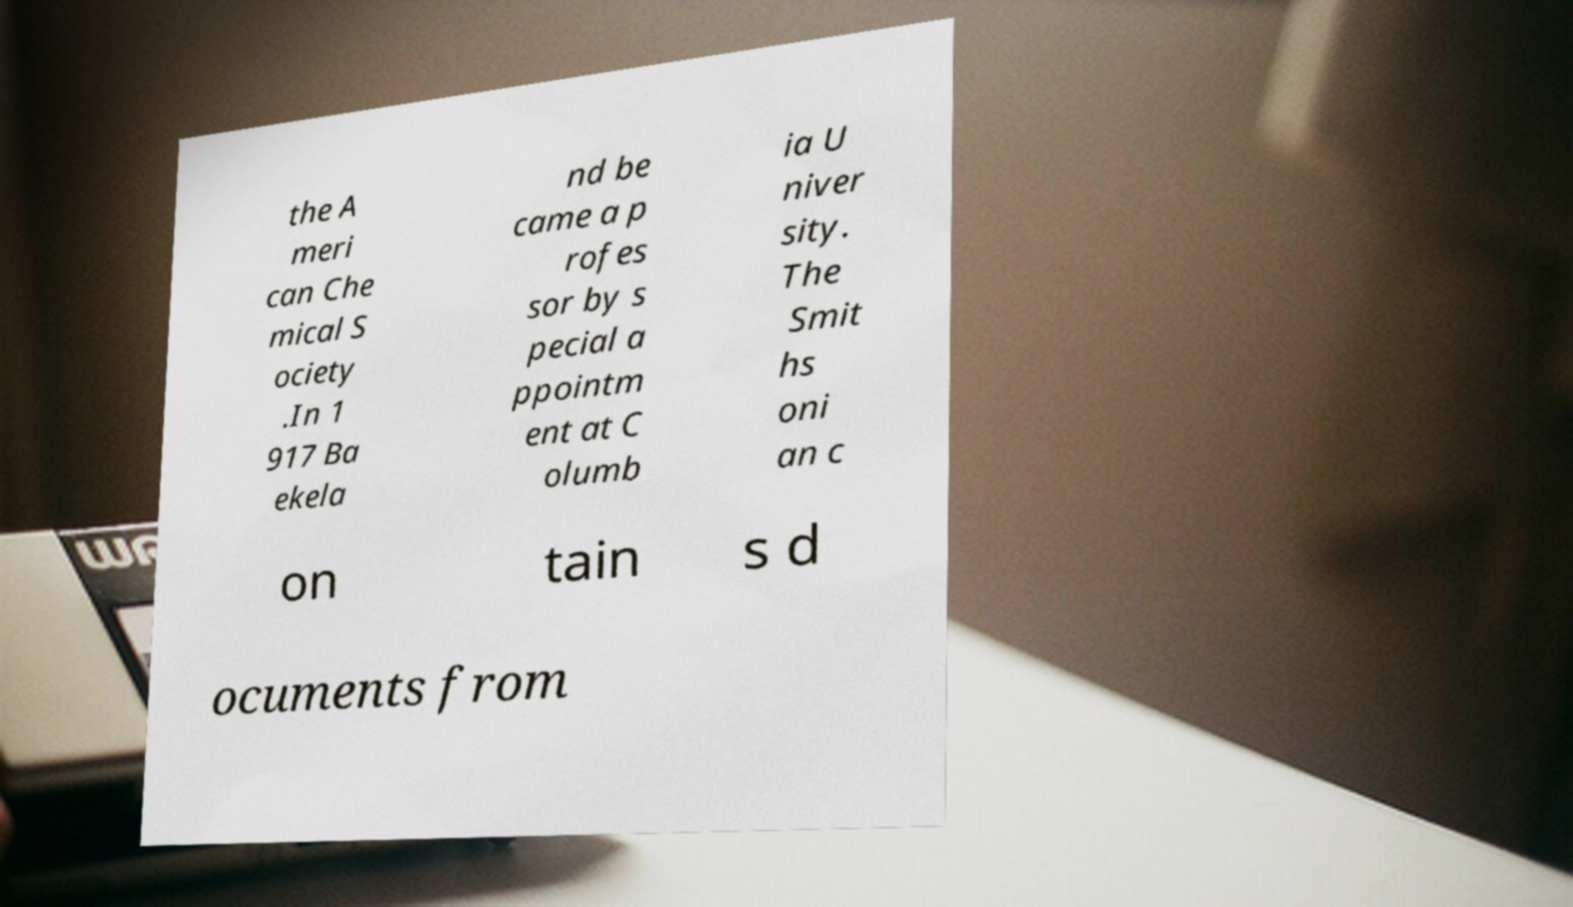What messages or text are displayed in this image? I need them in a readable, typed format. the A meri can Che mical S ociety .In 1 917 Ba ekela nd be came a p rofes sor by s pecial a ppointm ent at C olumb ia U niver sity. The Smit hs oni an c on tain s d ocuments from 